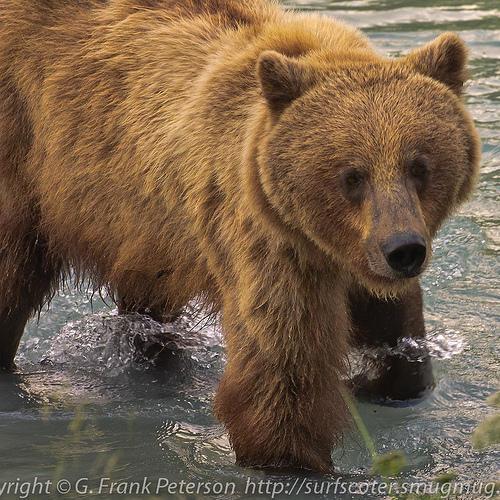How many bears are there?
Give a very brief answer. 1. How many ears does the bear have?
Give a very brief answer. 2. 